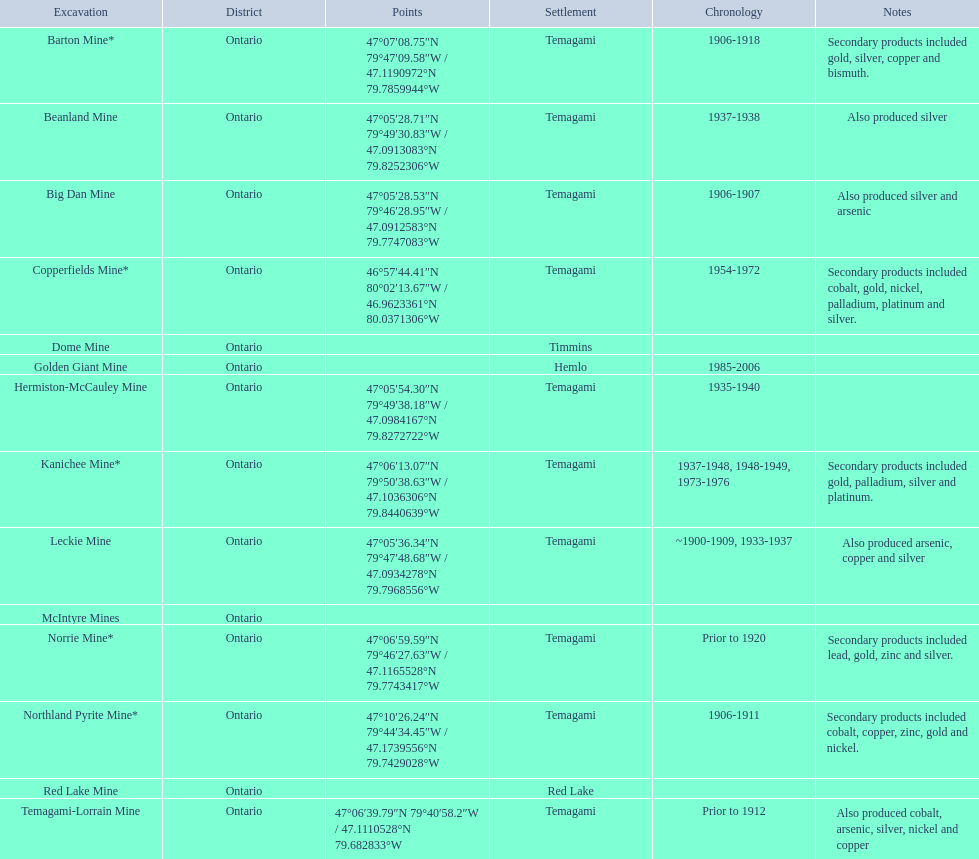Which mine was open longer, golden giant or beanland mine? Golden Giant Mine. 